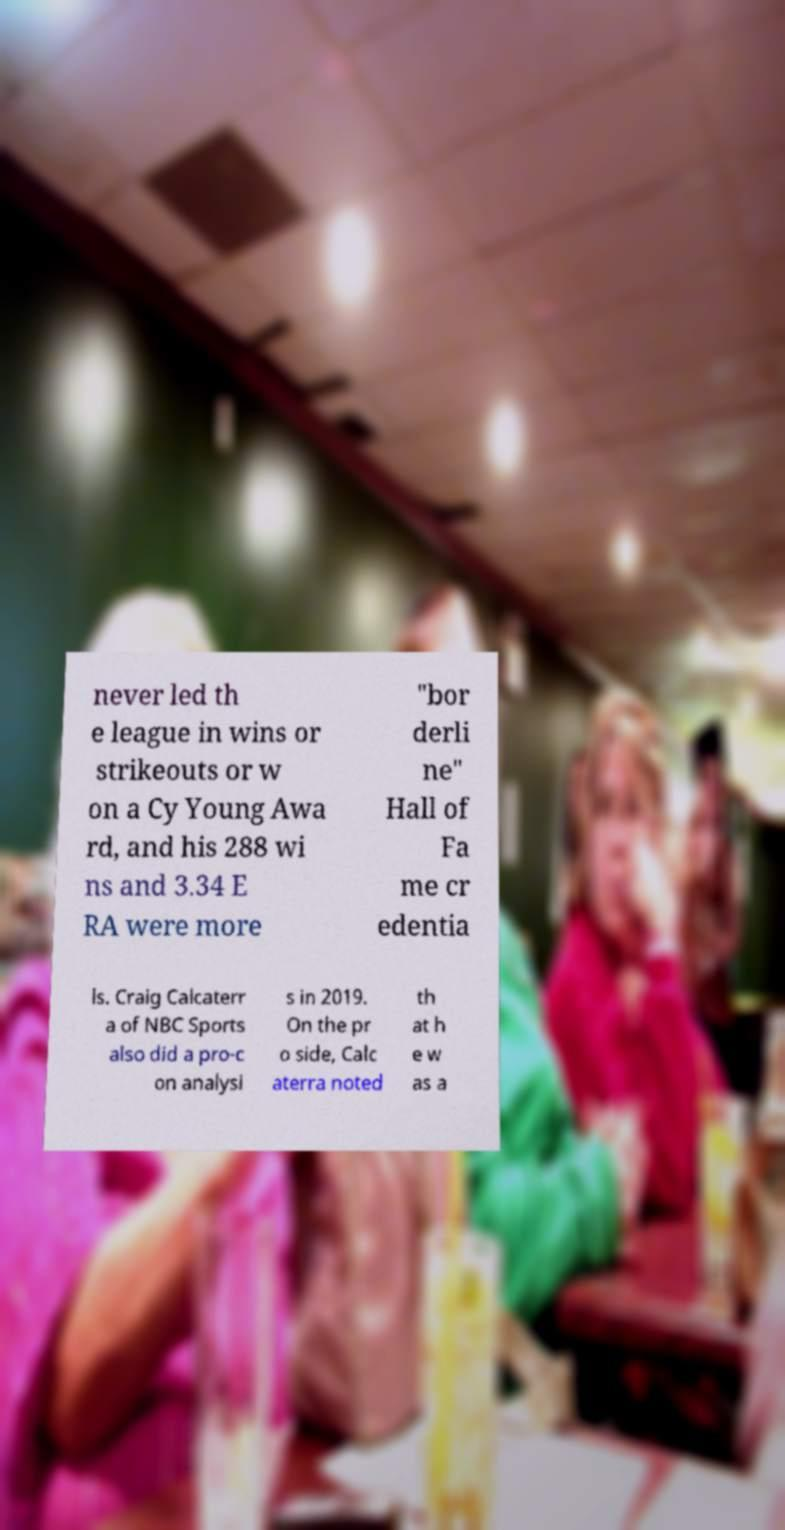Please read and relay the text visible in this image. What does it say? never led th e league in wins or strikeouts or w on a Cy Young Awa rd, and his 288 wi ns and 3.34 E RA were more "bor derli ne" Hall of Fa me cr edentia ls. Craig Calcaterr a of NBC Sports also did a pro-c on analysi s in 2019. On the pr o side, Calc aterra noted th at h e w as a 